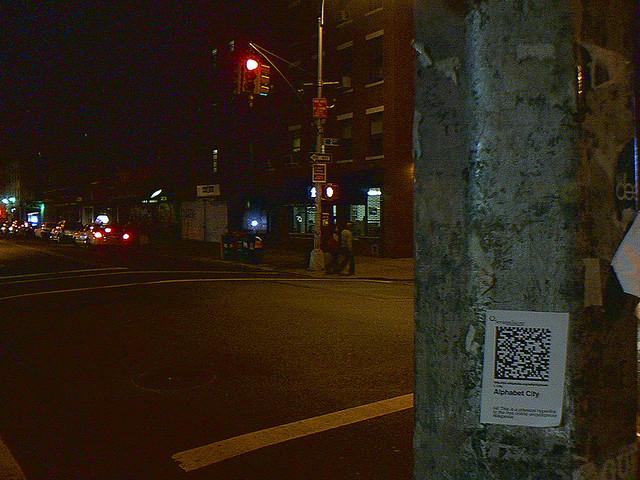Why are yellow lines painted in the street?
Keep it brief. Crosswalk. How many cars are visible?
Concise answer only. 4. Should cars be stopped at this light?
Give a very brief answer. Yes. What is the sticker on?
Concise answer only. Post. How has the sticker been defiled?
Short answer required. Torn. Is the signal light working?
Write a very short answer. Yes. Is it night?
Write a very short answer. Yes. Is the ground damp?
Be succinct. No. What color is the traffic light?
Keep it brief. Red. Why is it safe for the pedestrian to cross?
Keep it brief. No cars. Is there heavy traffic?
Give a very brief answer. No. What color is sticker?
Write a very short answer. White. Why is this object taped up?
Concise answer only. To keep on post. What color is the light?
Answer briefly. Red. What's the name on the street sign?
Keep it brief. Alphabet city. Where is the nearest crosswalk?
Concise answer only. Right behind post. 